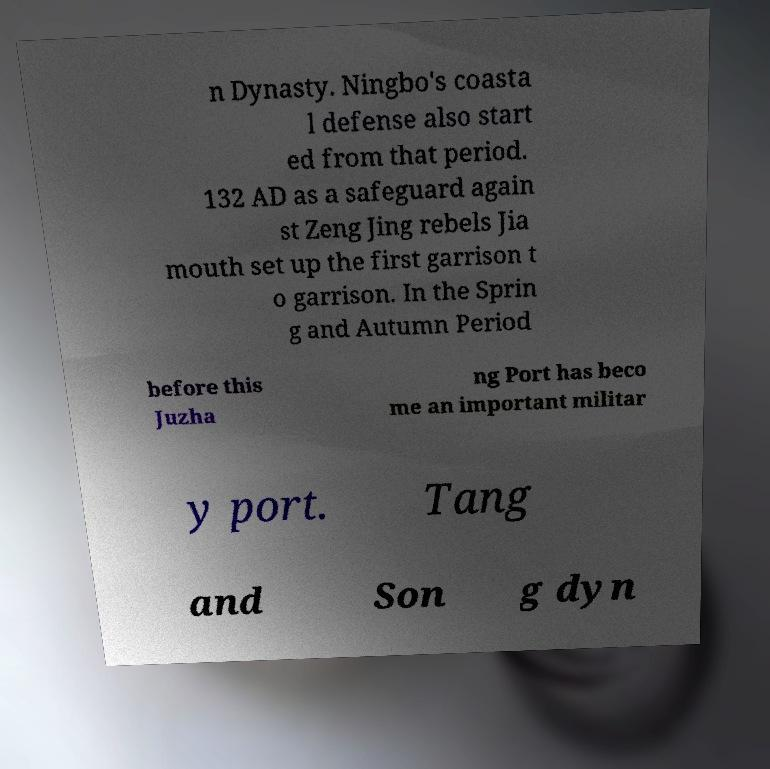Could you extract and type out the text from this image? n Dynasty. Ningbo's coasta l defense also start ed from that period. 132 AD as a safeguard again st Zeng Jing rebels Jia mouth set up the first garrison t o garrison. In the Sprin g and Autumn Period before this Juzha ng Port has beco me an important militar y port. Tang and Son g dyn 